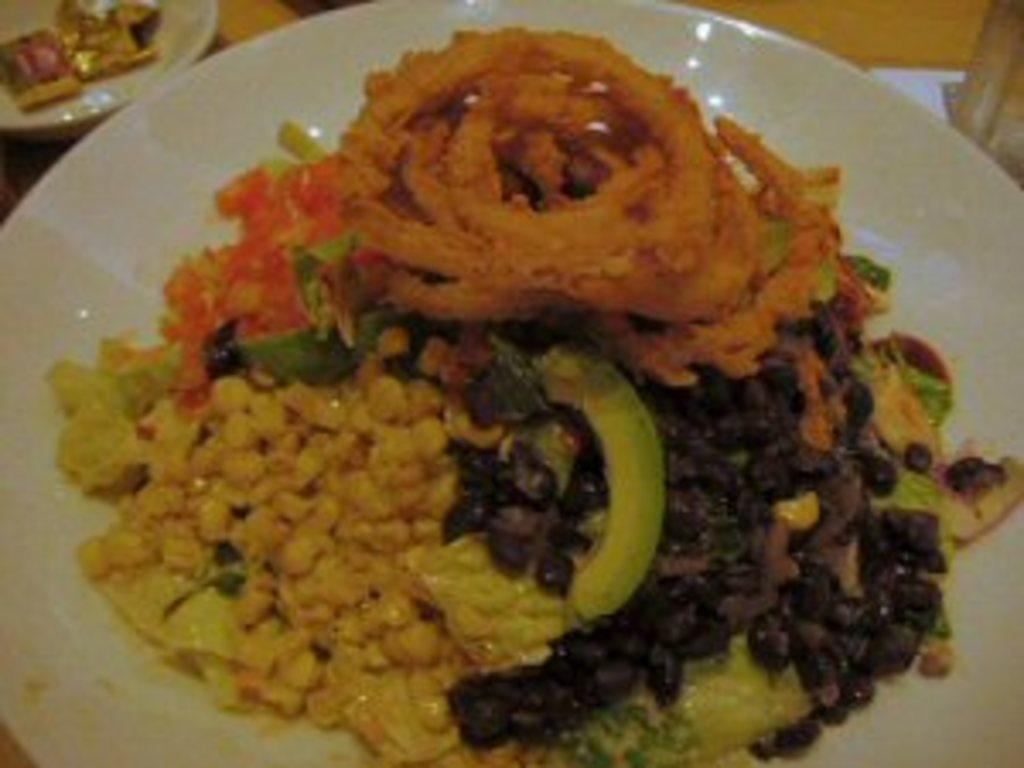What is placed on the white plate in the image? There are eatables placed on a white plate in the image. Can you describe any other objects visible in the image? There are other objects in the left top corner of the image. What type of money is being burned in the image? There is no money or burning activity present in the image. 